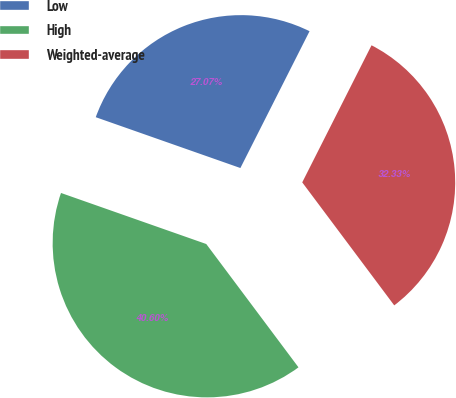<chart> <loc_0><loc_0><loc_500><loc_500><pie_chart><fcel>Low<fcel>High<fcel>Weighted-average<nl><fcel>27.07%<fcel>40.6%<fcel>32.33%<nl></chart> 